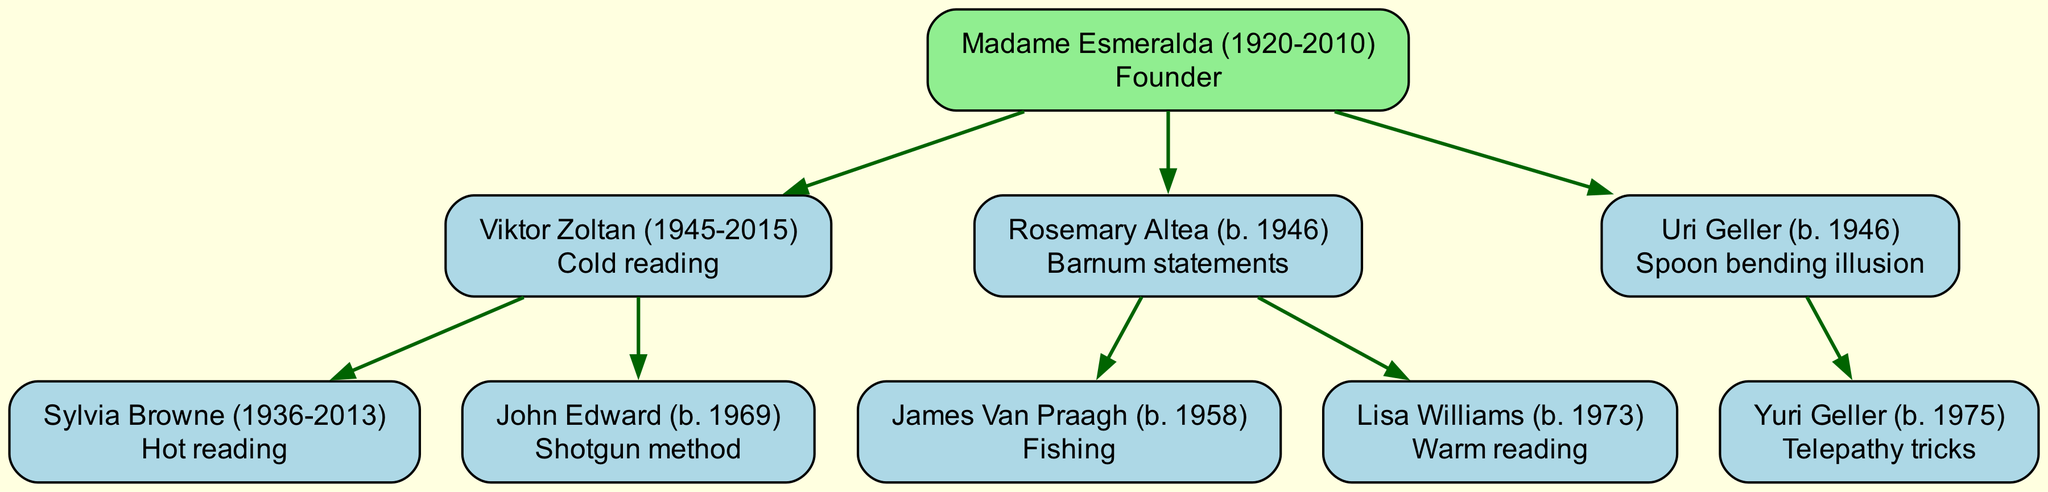What is the name of the founder of this psychic family tree? The root of the family tree is labeled "Madame Esmeralda (1920-2010)," indicating that she is the founder.
Answer: Madame Esmeralda (1920-2010) How many mentors are directly under Viktor Zoltan? Viktor Zoltan has two direct children in the diagram, Sylvia Browne and John Edward, which indicates he has two mentees.
Answer: 2 Which technique is associated with Rosemary Altea? The node representing Rosemary Altea contains the phrase "Barnum statements," indicating that this is the technique she is known for.
Answer: Barnum statements Who is John Edward's mentor? By examining the family tree, it can be seen that John Edward is directly under Viktor Zoltan, indicating that he is mentored by Viktor Zoltan.
Answer: Viktor Zoltan What is the relationship between Lisa Williams and James Van Praagh? Lisa Williams and James Van Praagh are both children of Rosemary Altea, indicating that they share a direct mentor and are therefore siblings in the context of mentorship.
Answer: Siblings What technique is used by the youngest child in the tree? The youngest child, Yuri Geller, is under Uri Geller and is associated with "Telepathy tricks," which identifies his fraudulent techniques.
Answer: Telepathy tricks How many techniques are listed in the family tree? Each mentor in the tree is associated with their specific technique, and by counting the unique techniques, we find a total of six: Cold reading, Hot reading, Shotgun method, Barnum statements, Fishing, and Warm reading.
Answer: 6 Which individual's technique involves "Spoon bending illusion"? The node for Uri Geller indicates that he is associated with the technique "Spoon bending illusion."
Answer: Uri Geller Who are the children of Madame Esmeralda? The diagram shows that Madame Esmeralda has three children: Viktor Zoltan, Rosemary Altea, and Uri Geller.
Answer: Viktor Zoltan, Rosemary Altea, Uri Geller 